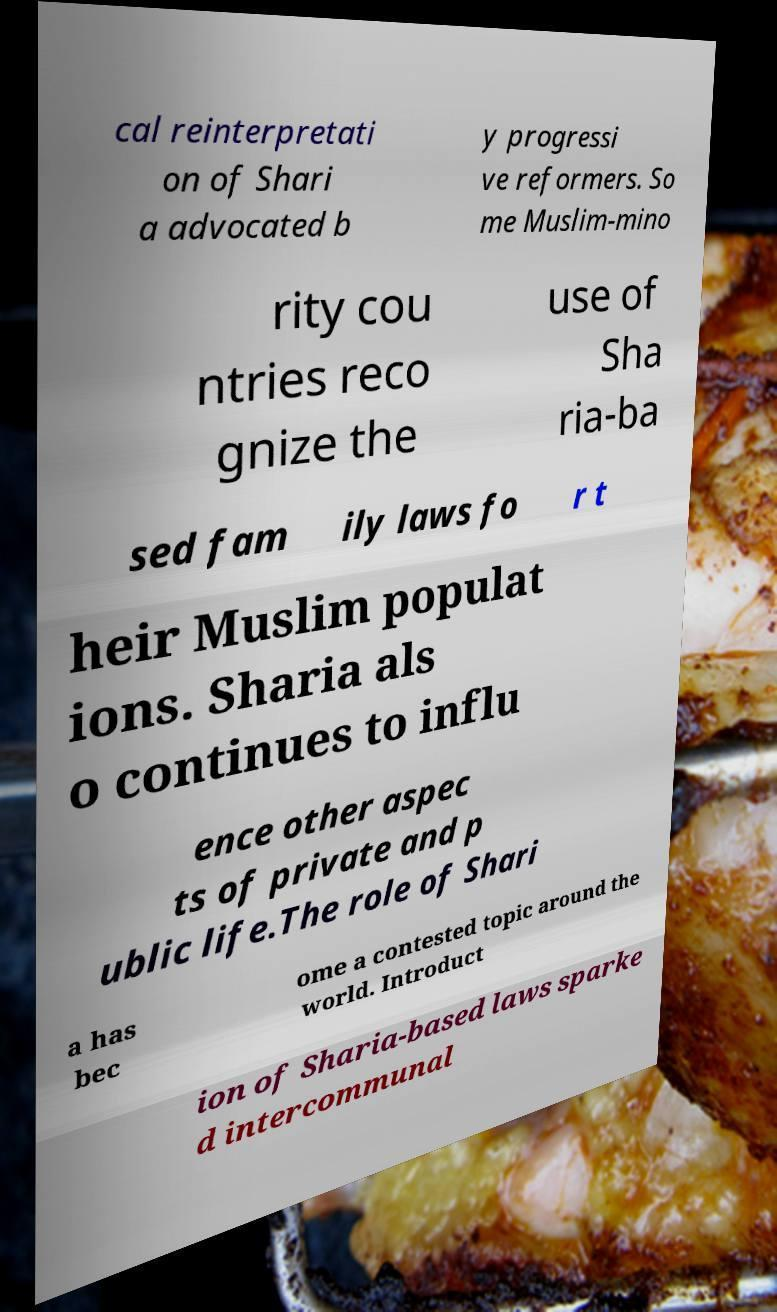Please identify and transcribe the text found in this image. cal reinterpretati on of Shari a advocated b y progressi ve reformers. So me Muslim-mino rity cou ntries reco gnize the use of Sha ria-ba sed fam ily laws fo r t heir Muslim populat ions. Sharia als o continues to influ ence other aspec ts of private and p ublic life.The role of Shari a has bec ome a contested topic around the world. Introduct ion of Sharia-based laws sparke d intercommunal 